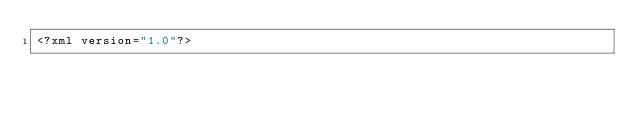<code> <loc_0><loc_0><loc_500><loc_500><_HTML_><?xml version="1.0"?></code> 